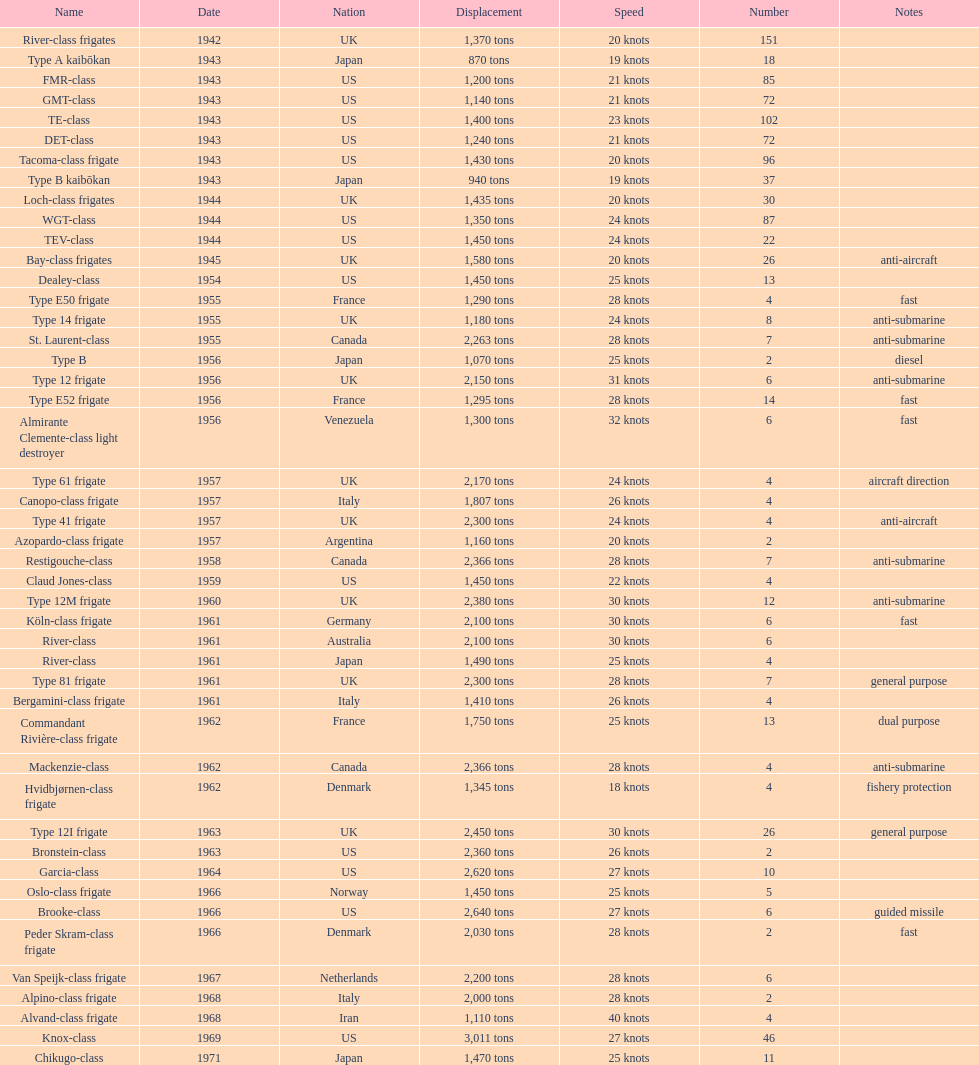In 1968, italy employed the alpino-class frigate - what was its highest achievable speed? 28 knots. 